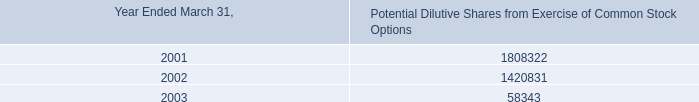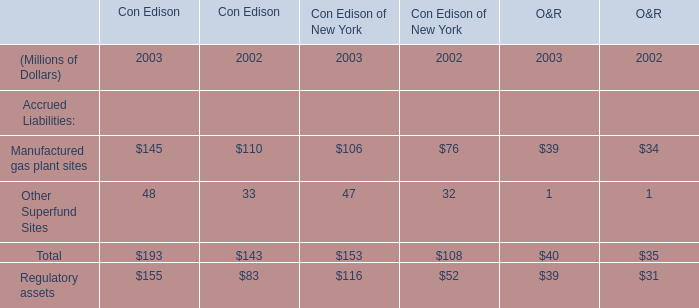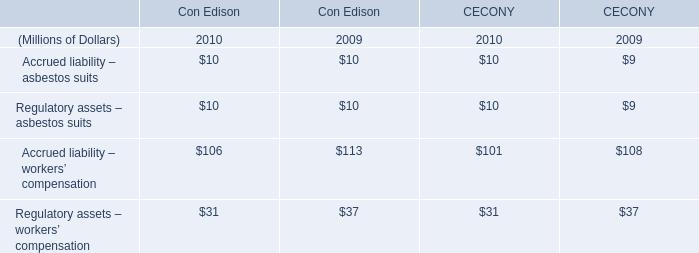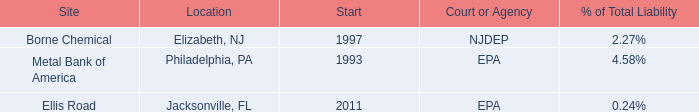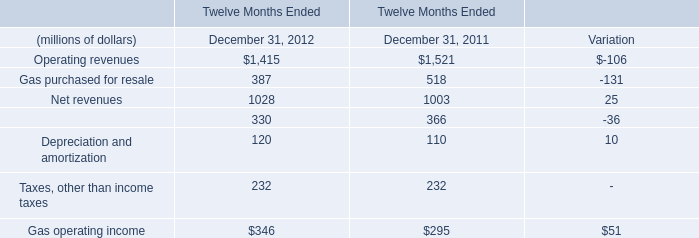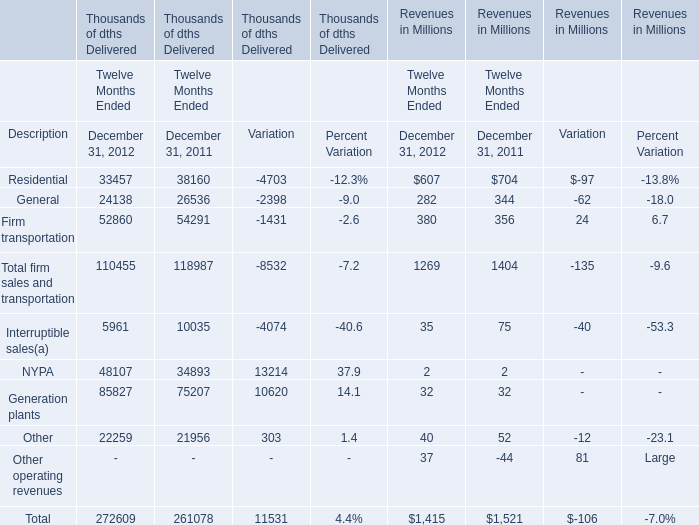what is the difference in amortized cost between 2002 and 2003? 
Computations: (9877000 - 25654000)
Answer: -15777000.0. 